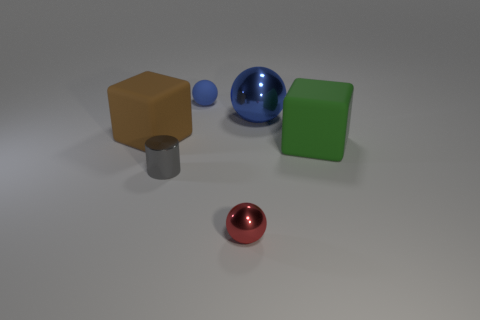The object that is on the left side of the small matte object and behind the gray thing has what shape?
Keep it short and to the point. Cube. Are there an equal number of rubber cubes right of the cylinder and small blue objects that are on the left side of the big green rubber thing?
Provide a succinct answer. Yes. What number of things are red spheres or large blue spheres?
Keep it short and to the point. 2. What is the color of the other shiny object that is the same size as the gray object?
Your answer should be compact. Red. How many things are either spheres in front of the big shiny sphere or rubber objects on the right side of the small blue object?
Keep it short and to the point. 2. Are there the same number of small metallic spheres right of the large green block and green shiny cylinders?
Ensure brevity in your answer.  Yes. Does the cube to the left of the green cube have the same size as the metal sphere that is in front of the small gray cylinder?
Offer a very short reply. No. What number of other objects are there of the same size as the gray metallic thing?
Provide a short and direct response. 2. Are there any objects on the right side of the cube behind the rubber object on the right side of the blue rubber sphere?
Ensure brevity in your answer.  Yes. Is there any other thing of the same color as the big metal thing?
Keep it short and to the point. Yes. 